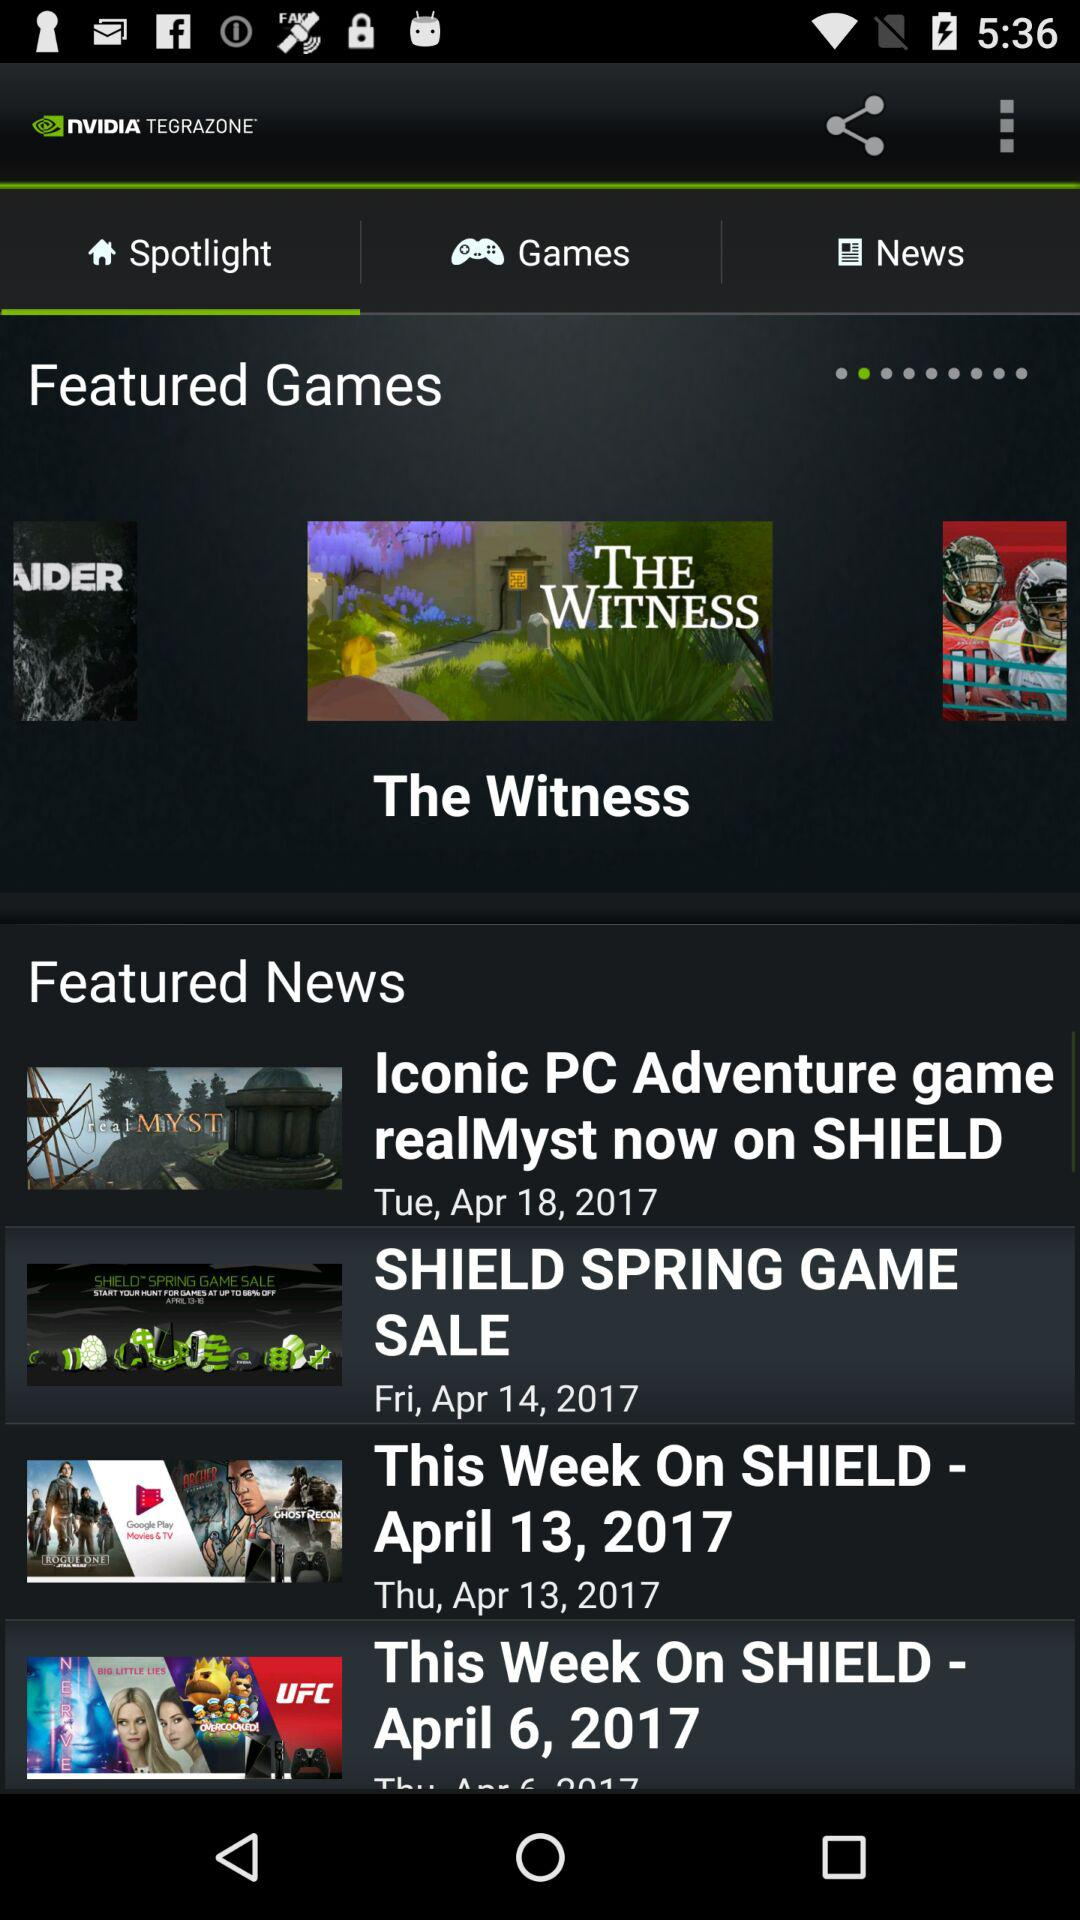What day was the news about the iconic PC adventure game posted? The day was Tuesday. 